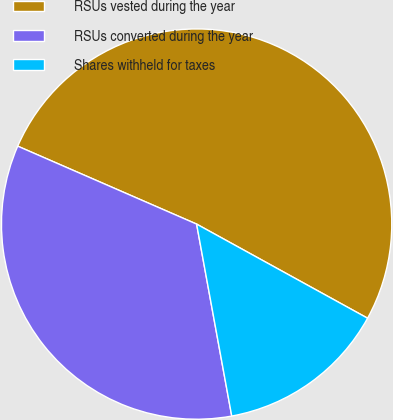Convert chart to OTSL. <chart><loc_0><loc_0><loc_500><loc_500><pie_chart><fcel>RSUs vested during the year<fcel>RSUs converted during the year<fcel>Shares withheld for taxes<nl><fcel>51.47%<fcel>34.42%<fcel>14.11%<nl></chart> 